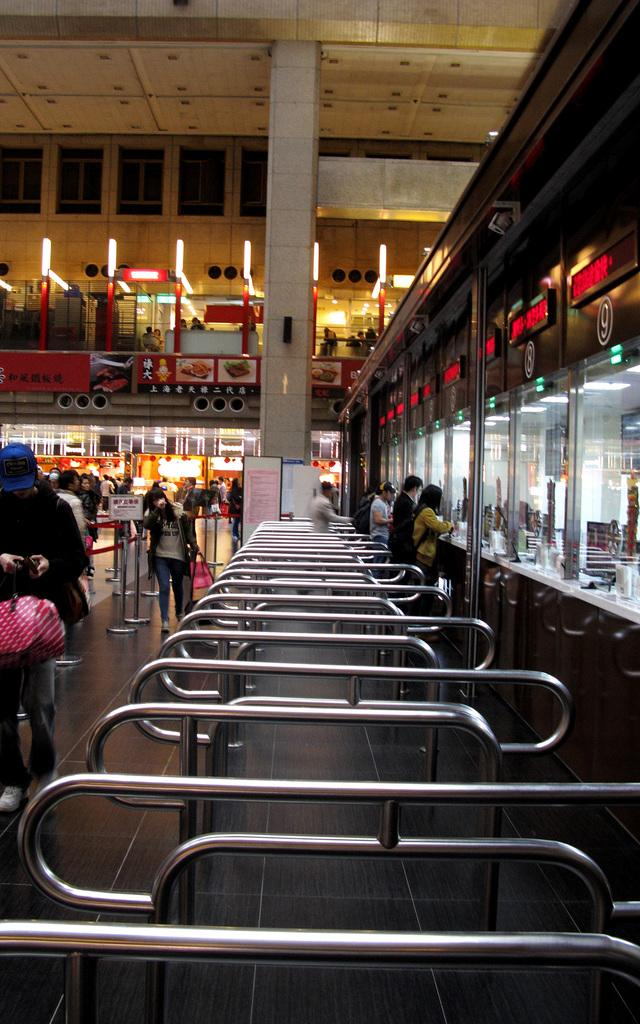What is the main subject of the image? The main subject of the image is a crowd. What objects can be seen in the image? Metal rods and glasses are present in the image. What type of establishments are visible in the image? Shops are visible in the image. What can be seen in the background of the image? Buildings, lights, and windows are visible in the background of the image. Where might this image have been taken? The image may have been taken in a mall. What type of map is being discussed by the crowd in the image? There is no map present in the image, nor is there any indication of a discussion taking place. 